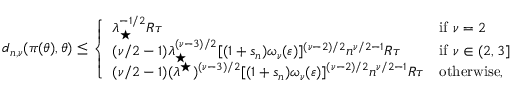Convert formula to latex. <formula><loc_0><loc_0><loc_500><loc_500>\begin{array} { r } { d _ { n , \nu } ( \pi ( \theta ) , \theta ) \leq \left \{ \begin{array} { l l } { \lambda _ { ^ { * } } ^ { - 1 / 2 } R \tau } & { i f \nu = 2 } \\ { ( \nu / 2 - 1 ) \lambda _ { ^ { * } } ^ { ( \nu - 3 ) / 2 } [ ( 1 + s _ { n } ) \omega _ { \nu } ( \varepsilon ) ] ^ { ( \nu - 2 ) / 2 } n ^ { \nu / 2 - 1 } R \tau } & { i f \nu \in ( 2 , 3 ] } \\ { ( \nu / 2 - 1 ) ( \lambda ^ { ^ { * } } ) ^ { ( \nu - 3 ) / 2 } [ ( 1 + s _ { n } ) \omega _ { \nu } ( \varepsilon ) ] ^ { ( \nu - 2 ) / 2 } n ^ { \nu / 2 - 1 } R \tau } & { o t h e r w i s e , } \end{array} } \end{array}</formula> 